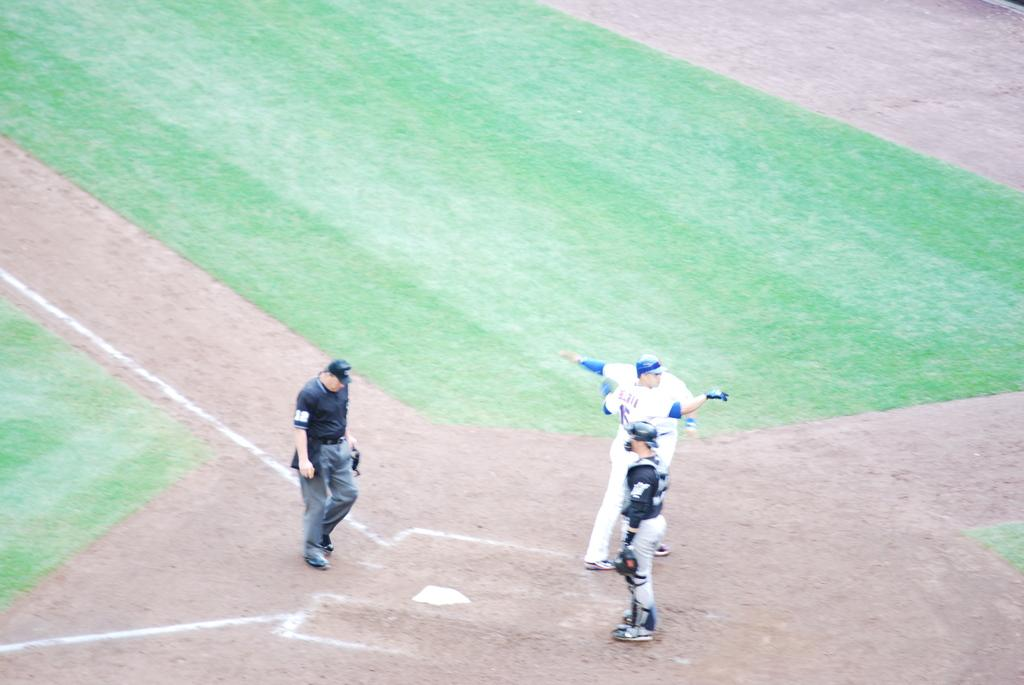What is the main subject of the image? The main subject of the image is people standing in the center. What can be seen below the people in the image? Ground is visible at the bottom of the image. What type of eggs can be seen in the image? There are no eggs present in the image. 